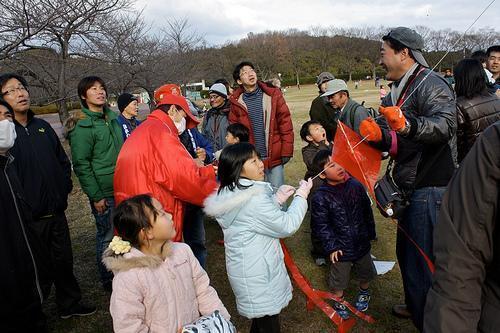How many people are visible?
Give a very brief answer. 10. 